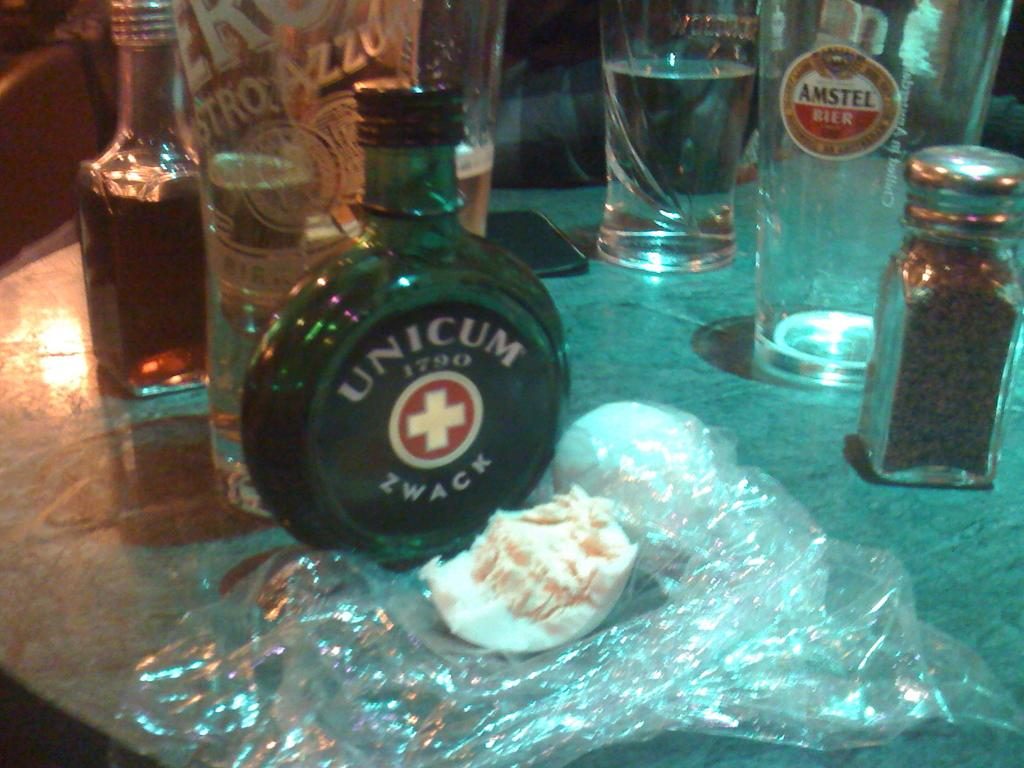What type of furniture is present in the image? There is a table in the image. What items can be seen on the table? There are bottles, glasses, a jar, a mobile, food items, and a cover on the table. How many containers are visible on the table? There are at least four containers visible on the table: bottles, a jar, glasses, and a cover. What letters are being delivered by the vessel in the image? There is no vessel or letters present in the image. 